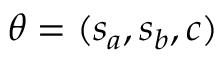<formula> <loc_0><loc_0><loc_500><loc_500>\theta = ( s _ { a } , s _ { b } , c )</formula> 